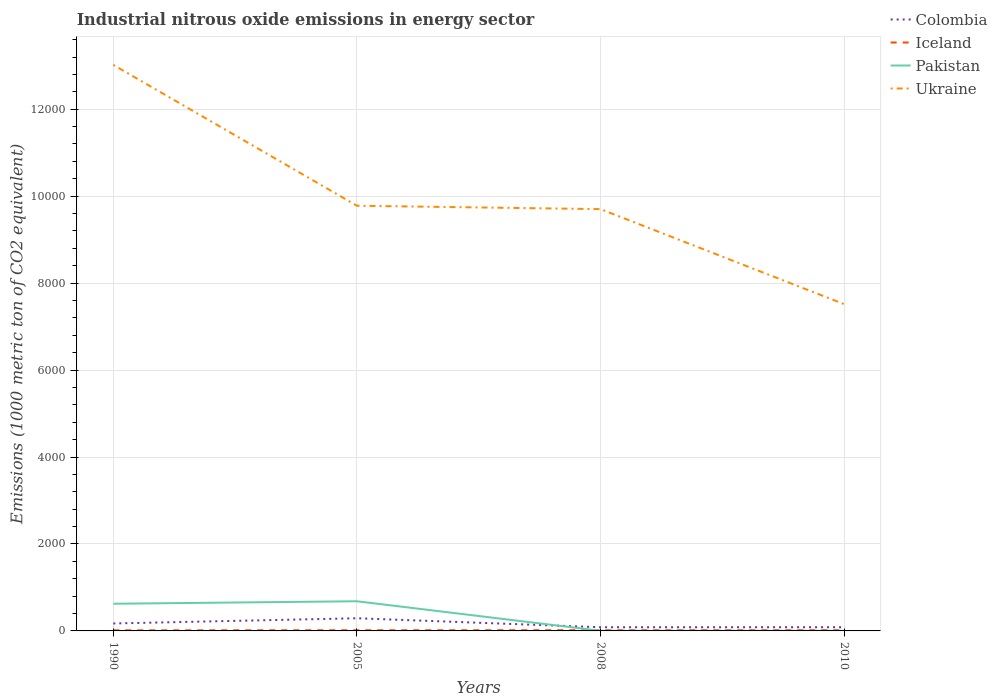Across all years, what is the maximum amount of industrial nitrous oxide emitted in Ukraine?
Offer a very short reply. 7516.9. What is the total amount of industrial nitrous oxide emitted in Pakistan in the graph?
Make the answer very short. -57.4. What is the difference between the highest and the second highest amount of industrial nitrous oxide emitted in Iceland?
Offer a very short reply. 3.7. Is the amount of industrial nitrous oxide emitted in Ukraine strictly greater than the amount of industrial nitrous oxide emitted in Colombia over the years?
Offer a terse response. No. How many lines are there?
Provide a short and direct response. 4. What is the difference between two consecutive major ticks on the Y-axis?
Provide a short and direct response. 2000. Does the graph contain any zero values?
Your answer should be very brief. No. Does the graph contain grids?
Offer a terse response. Yes. Where does the legend appear in the graph?
Offer a terse response. Top right. How are the legend labels stacked?
Provide a short and direct response. Vertical. What is the title of the graph?
Keep it short and to the point. Industrial nitrous oxide emissions in energy sector. What is the label or title of the X-axis?
Give a very brief answer. Years. What is the label or title of the Y-axis?
Keep it short and to the point. Emissions (1000 metric ton of CO2 equivalent). What is the Emissions (1000 metric ton of CO2 equivalent) in Colombia in 1990?
Ensure brevity in your answer.  171.6. What is the Emissions (1000 metric ton of CO2 equivalent) of Iceland in 1990?
Give a very brief answer. 14. What is the Emissions (1000 metric ton of CO2 equivalent) in Pakistan in 1990?
Your answer should be compact. 625. What is the Emissions (1000 metric ton of CO2 equivalent) in Ukraine in 1990?
Provide a short and direct response. 1.30e+04. What is the Emissions (1000 metric ton of CO2 equivalent) of Colombia in 2005?
Provide a short and direct response. 291.3. What is the Emissions (1000 metric ton of CO2 equivalent) of Pakistan in 2005?
Keep it short and to the point. 682.4. What is the Emissions (1000 metric ton of CO2 equivalent) in Ukraine in 2005?
Your answer should be compact. 9779.9. What is the Emissions (1000 metric ton of CO2 equivalent) of Colombia in 2008?
Provide a succinct answer. 84.7. What is the Emissions (1000 metric ton of CO2 equivalent) in Iceland in 2008?
Make the answer very short. 16.7. What is the Emissions (1000 metric ton of CO2 equivalent) in Ukraine in 2008?
Ensure brevity in your answer.  9701.8. What is the Emissions (1000 metric ton of CO2 equivalent) of Colombia in 2010?
Provide a succinct answer. 85.2. What is the Emissions (1000 metric ton of CO2 equivalent) in Iceland in 2010?
Offer a terse response. 17.7. What is the Emissions (1000 metric ton of CO2 equivalent) in Ukraine in 2010?
Offer a very short reply. 7516.9. Across all years, what is the maximum Emissions (1000 metric ton of CO2 equivalent) in Colombia?
Make the answer very short. 291.3. Across all years, what is the maximum Emissions (1000 metric ton of CO2 equivalent) in Iceland?
Keep it short and to the point. 17.7. Across all years, what is the maximum Emissions (1000 metric ton of CO2 equivalent) of Pakistan?
Your answer should be very brief. 682.4. Across all years, what is the maximum Emissions (1000 metric ton of CO2 equivalent) in Ukraine?
Offer a terse response. 1.30e+04. Across all years, what is the minimum Emissions (1000 metric ton of CO2 equivalent) of Colombia?
Ensure brevity in your answer.  84.7. Across all years, what is the minimum Emissions (1000 metric ton of CO2 equivalent) in Iceland?
Ensure brevity in your answer.  14. Across all years, what is the minimum Emissions (1000 metric ton of CO2 equivalent) of Pakistan?
Your answer should be compact. 3.6. Across all years, what is the minimum Emissions (1000 metric ton of CO2 equivalent) of Ukraine?
Give a very brief answer. 7516.9. What is the total Emissions (1000 metric ton of CO2 equivalent) in Colombia in the graph?
Offer a very short reply. 632.8. What is the total Emissions (1000 metric ton of CO2 equivalent) in Iceland in the graph?
Give a very brief answer. 63.7. What is the total Emissions (1000 metric ton of CO2 equivalent) of Pakistan in the graph?
Keep it short and to the point. 1314.7. What is the total Emissions (1000 metric ton of CO2 equivalent) in Ukraine in the graph?
Provide a succinct answer. 4.00e+04. What is the difference between the Emissions (1000 metric ton of CO2 equivalent) of Colombia in 1990 and that in 2005?
Your answer should be very brief. -119.7. What is the difference between the Emissions (1000 metric ton of CO2 equivalent) of Pakistan in 1990 and that in 2005?
Give a very brief answer. -57.4. What is the difference between the Emissions (1000 metric ton of CO2 equivalent) in Ukraine in 1990 and that in 2005?
Offer a terse response. 3240.1. What is the difference between the Emissions (1000 metric ton of CO2 equivalent) in Colombia in 1990 and that in 2008?
Your response must be concise. 86.9. What is the difference between the Emissions (1000 metric ton of CO2 equivalent) of Pakistan in 1990 and that in 2008?
Give a very brief answer. 621.4. What is the difference between the Emissions (1000 metric ton of CO2 equivalent) of Ukraine in 1990 and that in 2008?
Give a very brief answer. 3318.2. What is the difference between the Emissions (1000 metric ton of CO2 equivalent) of Colombia in 1990 and that in 2010?
Give a very brief answer. 86.4. What is the difference between the Emissions (1000 metric ton of CO2 equivalent) of Pakistan in 1990 and that in 2010?
Give a very brief answer. 621.3. What is the difference between the Emissions (1000 metric ton of CO2 equivalent) of Ukraine in 1990 and that in 2010?
Keep it short and to the point. 5503.1. What is the difference between the Emissions (1000 metric ton of CO2 equivalent) in Colombia in 2005 and that in 2008?
Offer a terse response. 206.6. What is the difference between the Emissions (1000 metric ton of CO2 equivalent) of Pakistan in 2005 and that in 2008?
Your answer should be very brief. 678.8. What is the difference between the Emissions (1000 metric ton of CO2 equivalent) in Ukraine in 2005 and that in 2008?
Provide a short and direct response. 78.1. What is the difference between the Emissions (1000 metric ton of CO2 equivalent) of Colombia in 2005 and that in 2010?
Keep it short and to the point. 206.1. What is the difference between the Emissions (1000 metric ton of CO2 equivalent) of Iceland in 2005 and that in 2010?
Give a very brief answer. -2.4. What is the difference between the Emissions (1000 metric ton of CO2 equivalent) of Pakistan in 2005 and that in 2010?
Offer a terse response. 678.7. What is the difference between the Emissions (1000 metric ton of CO2 equivalent) in Ukraine in 2005 and that in 2010?
Your answer should be very brief. 2263. What is the difference between the Emissions (1000 metric ton of CO2 equivalent) of Colombia in 2008 and that in 2010?
Your response must be concise. -0.5. What is the difference between the Emissions (1000 metric ton of CO2 equivalent) of Ukraine in 2008 and that in 2010?
Make the answer very short. 2184.9. What is the difference between the Emissions (1000 metric ton of CO2 equivalent) in Colombia in 1990 and the Emissions (1000 metric ton of CO2 equivalent) in Iceland in 2005?
Make the answer very short. 156.3. What is the difference between the Emissions (1000 metric ton of CO2 equivalent) in Colombia in 1990 and the Emissions (1000 metric ton of CO2 equivalent) in Pakistan in 2005?
Provide a short and direct response. -510.8. What is the difference between the Emissions (1000 metric ton of CO2 equivalent) in Colombia in 1990 and the Emissions (1000 metric ton of CO2 equivalent) in Ukraine in 2005?
Provide a short and direct response. -9608.3. What is the difference between the Emissions (1000 metric ton of CO2 equivalent) of Iceland in 1990 and the Emissions (1000 metric ton of CO2 equivalent) of Pakistan in 2005?
Make the answer very short. -668.4. What is the difference between the Emissions (1000 metric ton of CO2 equivalent) in Iceland in 1990 and the Emissions (1000 metric ton of CO2 equivalent) in Ukraine in 2005?
Keep it short and to the point. -9765.9. What is the difference between the Emissions (1000 metric ton of CO2 equivalent) in Pakistan in 1990 and the Emissions (1000 metric ton of CO2 equivalent) in Ukraine in 2005?
Make the answer very short. -9154.9. What is the difference between the Emissions (1000 metric ton of CO2 equivalent) in Colombia in 1990 and the Emissions (1000 metric ton of CO2 equivalent) in Iceland in 2008?
Offer a very short reply. 154.9. What is the difference between the Emissions (1000 metric ton of CO2 equivalent) of Colombia in 1990 and the Emissions (1000 metric ton of CO2 equivalent) of Pakistan in 2008?
Ensure brevity in your answer.  168. What is the difference between the Emissions (1000 metric ton of CO2 equivalent) in Colombia in 1990 and the Emissions (1000 metric ton of CO2 equivalent) in Ukraine in 2008?
Provide a short and direct response. -9530.2. What is the difference between the Emissions (1000 metric ton of CO2 equivalent) in Iceland in 1990 and the Emissions (1000 metric ton of CO2 equivalent) in Ukraine in 2008?
Give a very brief answer. -9687.8. What is the difference between the Emissions (1000 metric ton of CO2 equivalent) of Pakistan in 1990 and the Emissions (1000 metric ton of CO2 equivalent) of Ukraine in 2008?
Give a very brief answer. -9076.8. What is the difference between the Emissions (1000 metric ton of CO2 equivalent) of Colombia in 1990 and the Emissions (1000 metric ton of CO2 equivalent) of Iceland in 2010?
Your answer should be compact. 153.9. What is the difference between the Emissions (1000 metric ton of CO2 equivalent) in Colombia in 1990 and the Emissions (1000 metric ton of CO2 equivalent) in Pakistan in 2010?
Your answer should be compact. 167.9. What is the difference between the Emissions (1000 metric ton of CO2 equivalent) of Colombia in 1990 and the Emissions (1000 metric ton of CO2 equivalent) of Ukraine in 2010?
Keep it short and to the point. -7345.3. What is the difference between the Emissions (1000 metric ton of CO2 equivalent) in Iceland in 1990 and the Emissions (1000 metric ton of CO2 equivalent) in Ukraine in 2010?
Make the answer very short. -7502.9. What is the difference between the Emissions (1000 metric ton of CO2 equivalent) of Pakistan in 1990 and the Emissions (1000 metric ton of CO2 equivalent) of Ukraine in 2010?
Offer a very short reply. -6891.9. What is the difference between the Emissions (1000 metric ton of CO2 equivalent) of Colombia in 2005 and the Emissions (1000 metric ton of CO2 equivalent) of Iceland in 2008?
Offer a terse response. 274.6. What is the difference between the Emissions (1000 metric ton of CO2 equivalent) in Colombia in 2005 and the Emissions (1000 metric ton of CO2 equivalent) in Pakistan in 2008?
Provide a succinct answer. 287.7. What is the difference between the Emissions (1000 metric ton of CO2 equivalent) of Colombia in 2005 and the Emissions (1000 metric ton of CO2 equivalent) of Ukraine in 2008?
Keep it short and to the point. -9410.5. What is the difference between the Emissions (1000 metric ton of CO2 equivalent) in Iceland in 2005 and the Emissions (1000 metric ton of CO2 equivalent) in Ukraine in 2008?
Make the answer very short. -9686.5. What is the difference between the Emissions (1000 metric ton of CO2 equivalent) in Pakistan in 2005 and the Emissions (1000 metric ton of CO2 equivalent) in Ukraine in 2008?
Offer a very short reply. -9019.4. What is the difference between the Emissions (1000 metric ton of CO2 equivalent) of Colombia in 2005 and the Emissions (1000 metric ton of CO2 equivalent) of Iceland in 2010?
Provide a short and direct response. 273.6. What is the difference between the Emissions (1000 metric ton of CO2 equivalent) in Colombia in 2005 and the Emissions (1000 metric ton of CO2 equivalent) in Pakistan in 2010?
Offer a very short reply. 287.6. What is the difference between the Emissions (1000 metric ton of CO2 equivalent) in Colombia in 2005 and the Emissions (1000 metric ton of CO2 equivalent) in Ukraine in 2010?
Give a very brief answer. -7225.6. What is the difference between the Emissions (1000 metric ton of CO2 equivalent) of Iceland in 2005 and the Emissions (1000 metric ton of CO2 equivalent) of Ukraine in 2010?
Ensure brevity in your answer.  -7501.6. What is the difference between the Emissions (1000 metric ton of CO2 equivalent) in Pakistan in 2005 and the Emissions (1000 metric ton of CO2 equivalent) in Ukraine in 2010?
Your answer should be very brief. -6834.5. What is the difference between the Emissions (1000 metric ton of CO2 equivalent) in Colombia in 2008 and the Emissions (1000 metric ton of CO2 equivalent) in Iceland in 2010?
Offer a terse response. 67. What is the difference between the Emissions (1000 metric ton of CO2 equivalent) of Colombia in 2008 and the Emissions (1000 metric ton of CO2 equivalent) of Ukraine in 2010?
Offer a terse response. -7432.2. What is the difference between the Emissions (1000 metric ton of CO2 equivalent) in Iceland in 2008 and the Emissions (1000 metric ton of CO2 equivalent) in Ukraine in 2010?
Provide a short and direct response. -7500.2. What is the difference between the Emissions (1000 metric ton of CO2 equivalent) in Pakistan in 2008 and the Emissions (1000 metric ton of CO2 equivalent) in Ukraine in 2010?
Keep it short and to the point. -7513.3. What is the average Emissions (1000 metric ton of CO2 equivalent) in Colombia per year?
Provide a succinct answer. 158.2. What is the average Emissions (1000 metric ton of CO2 equivalent) of Iceland per year?
Ensure brevity in your answer.  15.93. What is the average Emissions (1000 metric ton of CO2 equivalent) of Pakistan per year?
Ensure brevity in your answer.  328.68. What is the average Emissions (1000 metric ton of CO2 equivalent) in Ukraine per year?
Your answer should be compact. 1.00e+04. In the year 1990, what is the difference between the Emissions (1000 metric ton of CO2 equivalent) in Colombia and Emissions (1000 metric ton of CO2 equivalent) in Iceland?
Your answer should be compact. 157.6. In the year 1990, what is the difference between the Emissions (1000 metric ton of CO2 equivalent) of Colombia and Emissions (1000 metric ton of CO2 equivalent) of Pakistan?
Make the answer very short. -453.4. In the year 1990, what is the difference between the Emissions (1000 metric ton of CO2 equivalent) in Colombia and Emissions (1000 metric ton of CO2 equivalent) in Ukraine?
Offer a very short reply. -1.28e+04. In the year 1990, what is the difference between the Emissions (1000 metric ton of CO2 equivalent) of Iceland and Emissions (1000 metric ton of CO2 equivalent) of Pakistan?
Your answer should be very brief. -611. In the year 1990, what is the difference between the Emissions (1000 metric ton of CO2 equivalent) in Iceland and Emissions (1000 metric ton of CO2 equivalent) in Ukraine?
Your answer should be very brief. -1.30e+04. In the year 1990, what is the difference between the Emissions (1000 metric ton of CO2 equivalent) in Pakistan and Emissions (1000 metric ton of CO2 equivalent) in Ukraine?
Provide a succinct answer. -1.24e+04. In the year 2005, what is the difference between the Emissions (1000 metric ton of CO2 equivalent) in Colombia and Emissions (1000 metric ton of CO2 equivalent) in Iceland?
Give a very brief answer. 276. In the year 2005, what is the difference between the Emissions (1000 metric ton of CO2 equivalent) in Colombia and Emissions (1000 metric ton of CO2 equivalent) in Pakistan?
Provide a short and direct response. -391.1. In the year 2005, what is the difference between the Emissions (1000 metric ton of CO2 equivalent) in Colombia and Emissions (1000 metric ton of CO2 equivalent) in Ukraine?
Provide a succinct answer. -9488.6. In the year 2005, what is the difference between the Emissions (1000 metric ton of CO2 equivalent) of Iceland and Emissions (1000 metric ton of CO2 equivalent) of Pakistan?
Ensure brevity in your answer.  -667.1. In the year 2005, what is the difference between the Emissions (1000 metric ton of CO2 equivalent) in Iceland and Emissions (1000 metric ton of CO2 equivalent) in Ukraine?
Ensure brevity in your answer.  -9764.6. In the year 2005, what is the difference between the Emissions (1000 metric ton of CO2 equivalent) of Pakistan and Emissions (1000 metric ton of CO2 equivalent) of Ukraine?
Make the answer very short. -9097.5. In the year 2008, what is the difference between the Emissions (1000 metric ton of CO2 equivalent) of Colombia and Emissions (1000 metric ton of CO2 equivalent) of Iceland?
Keep it short and to the point. 68. In the year 2008, what is the difference between the Emissions (1000 metric ton of CO2 equivalent) of Colombia and Emissions (1000 metric ton of CO2 equivalent) of Pakistan?
Provide a succinct answer. 81.1. In the year 2008, what is the difference between the Emissions (1000 metric ton of CO2 equivalent) in Colombia and Emissions (1000 metric ton of CO2 equivalent) in Ukraine?
Offer a terse response. -9617.1. In the year 2008, what is the difference between the Emissions (1000 metric ton of CO2 equivalent) in Iceland and Emissions (1000 metric ton of CO2 equivalent) in Pakistan?
Provide a short and direct response. 13.1. In the year 2008, what is the difference between the Emissions (1000 metric ton of CO2 equivalent) in Iceland and Emissions (1000 metric ton of CO2 equivalent) in Ukraine?
Your response must be concise. -9685.1. In the year 2008, what is the difference between the Emissions (1000 metric ton of CO2 equivalent) in Pakistan and Emissions (1000 metric ton of CO2 equivalent) in Ukraine?
Ensure brevity in your answer.  -9698.2. In the year 2010, what is the difference between the Emissions (1000 metric ton of CO2 equivalent) of Colombia and Emissions (1000 metric ton of CO2 equivalent) of Iceland?
Offer a terse response. 67.5. In the year 2010, what is the difference between the Emissions (1000 metric ton of CO2 equivalent) of Colombia and Emissions (1000 metric ton of CO2 equivalent) of Pakistan?
Your answer should be compact. 81.5. In the year 2010, what is the difference between the Emissions (1000 metric ton of CO2 equivalent) of Colombia and Emissions (1000 metric ton of CO2 equivalent) of Ukraine?
Your answer should be very brief. -7431.7. In the year 2010, what is the difference between the Emissions (1000 metric ton of CO2 equivalent) of Iceland and Emissions (1000 metric ton of CO2 equivalent) of Ukraine?
Your response must be concise. -7499.2. In the year 2010, what is the difference between the Emissions (1000 metric ton of CO2 equivalent) in Pakistan and Emissions (1000 metric ton of CO2 equivalent) in Ukraine?
Your response must be concise. -7513.2. What is the ratio of the Emissions (1000 metric ton of CO2 equivalent) in Colombia in 1990 to that in 2005?
Your response must be concise. 0.59. What is the ratio of the Emissions (1000 metric ton of CO2 equivalent) in Iceland in 1990 to that in 2005?
Provide a succinct answer. 0.92. What is the ratio of the Emissions (1000 metric ton of CO2 equivalent) in Pakistan in 1990 to that in 2005?
Offer a very short reply. 0.92. What is the ratio of the Emissions (1000 metric ton of CO2 equivalent) in Ukraine in 1990 to that in 2005?
Your answer should be very brief. 1.33. What is the ratio of the Emissions (1000 metric ton of CO2 equivalent) in Colombia in 1990 to that in 2008?
Keep it short and to the point. 2.03. What is the ratio of the Emissions (1000 metric ton of CO2 equivalent) in Iceland in 1990 to that in 2008?
Offer a terse response. 0.84. What is the ratio of the Emissions (1000 metric ton of CO2 equivalent) in Pakistan in 1990 to that in 2008?
Your answer should be very brief. 173.61. What is the ratio of the Emissions (1000 metric ton of CO2 equivalent) of Ukraine in 1990 to that in 2008?
Make the answer very short. 1.34. What is the ratio of the Emissions (1000 metric ton of CO2 equivalent) of Colombia in 1990 to that in 2010?
Provide a short and direct response. 2.01. What is the ratio of the Emissions (1000 metric ton of CO2 equivalent) in Iceland in 1990 to that in 2010?
Keep it short and to the point. 0.79. What is the ratio of the Emissions (1000 metric ton of CO2 equivalent) of Pakistan in 1990 to that in 2010?
Make the answer very short. 168.92. What is the ratio of the Emissions (1000 metric ton of CO2 equivalent) in Ukraine in 1990 to that in 2010?
Your answer should be compact. 1.73. What is the ratio of the Emissions (1000 metric ton of CO2 equivalent) in Colombia in 2005 to that in 2008?
Your answer should be very brief. 3.44. What is the ratio of the Emissions (1000 metric ton of CO2 equivalent) in Iceland in 2005 to that in 2008?
Offer a very short reply. 0.92. What is the ratio of the Emissions (1000 metric ton of CO2 equivalent) in Pakistan in 2005 to that in 2008?
Your response must be concise. 189.56. What is the ratio of the Emissions (1000 metric ton of CO2 equivalent) in Ukraine in 2005 to that in 2008?
Ensure brevity in your answer.  1.01. What is the ratio of the Emissions (1000 metric ton of CO2 equivalent) in Colombia in 2005 to that in 2010?
Offer a very short reply. 3.42. What is the ratio of the Emissions (1000 metric ton of CO2 equivalent) in Iceland in 2005 to that in 2010?
Provide a short and direct response. 0.86. What is the ratio of the Emissions (1000 metric ton of CO2 equivalent) in Pakistan in 2005 to that in 2010?
Provide a succinct answer. 184.43. What is the ratio of the Emissions (1000 metric ton of CO2 equivalent) of Ukraine in 2005 to that in 2010?
Offer a very short reply. 1.3. What is the ratio of the Emissions (1000 metric ton of CO2 equivalent) of Iceland in 2008 to that in 2010?
Offer a terse response. 0.94. What is the ratio of the Emissions (1000 metric ton of CO2 equivalent) in Pakistan in 2008 to that in 2010?
Offer a very short reply. 0.97. What is the ratio of the Emissions (1000 metric ton of CO2 equivalent) of Ukraine in 2008 to that in 2010?
Provide a succinct answer. 1.29. What is the difference between the highest and the second highest Emissions (1000 metric ton of CO2 equivalent) of Colombia?
Offer a very short reply. 119.7. What is the difference between the highest and the second highest Emissions (1000 metric ton of CO2 equivalent) of Pakistan?
Offer a very short reply. 57.4. What is the difference between the highest and the second highest Emissions (1000 metric ton of CO2 equivalent) in Ukraine?
Make the answer very short. 3240.1. What is the difference between the highest and the lowest Emissions (1000 metric ton of CO2 equivalent) in Colombia?
Make the answer very short. 206.6. What is the difference between the highest and the lowest Emissions (1000 metric ton of CO2 equivalent) in Pakistan?
Offer a terse response. 678.8. What is the difference between the highest and the lowest Emissions (1000 metric ton of CO2 equivalent) of Ukraine?
Make the answer very short. 5503.1. 